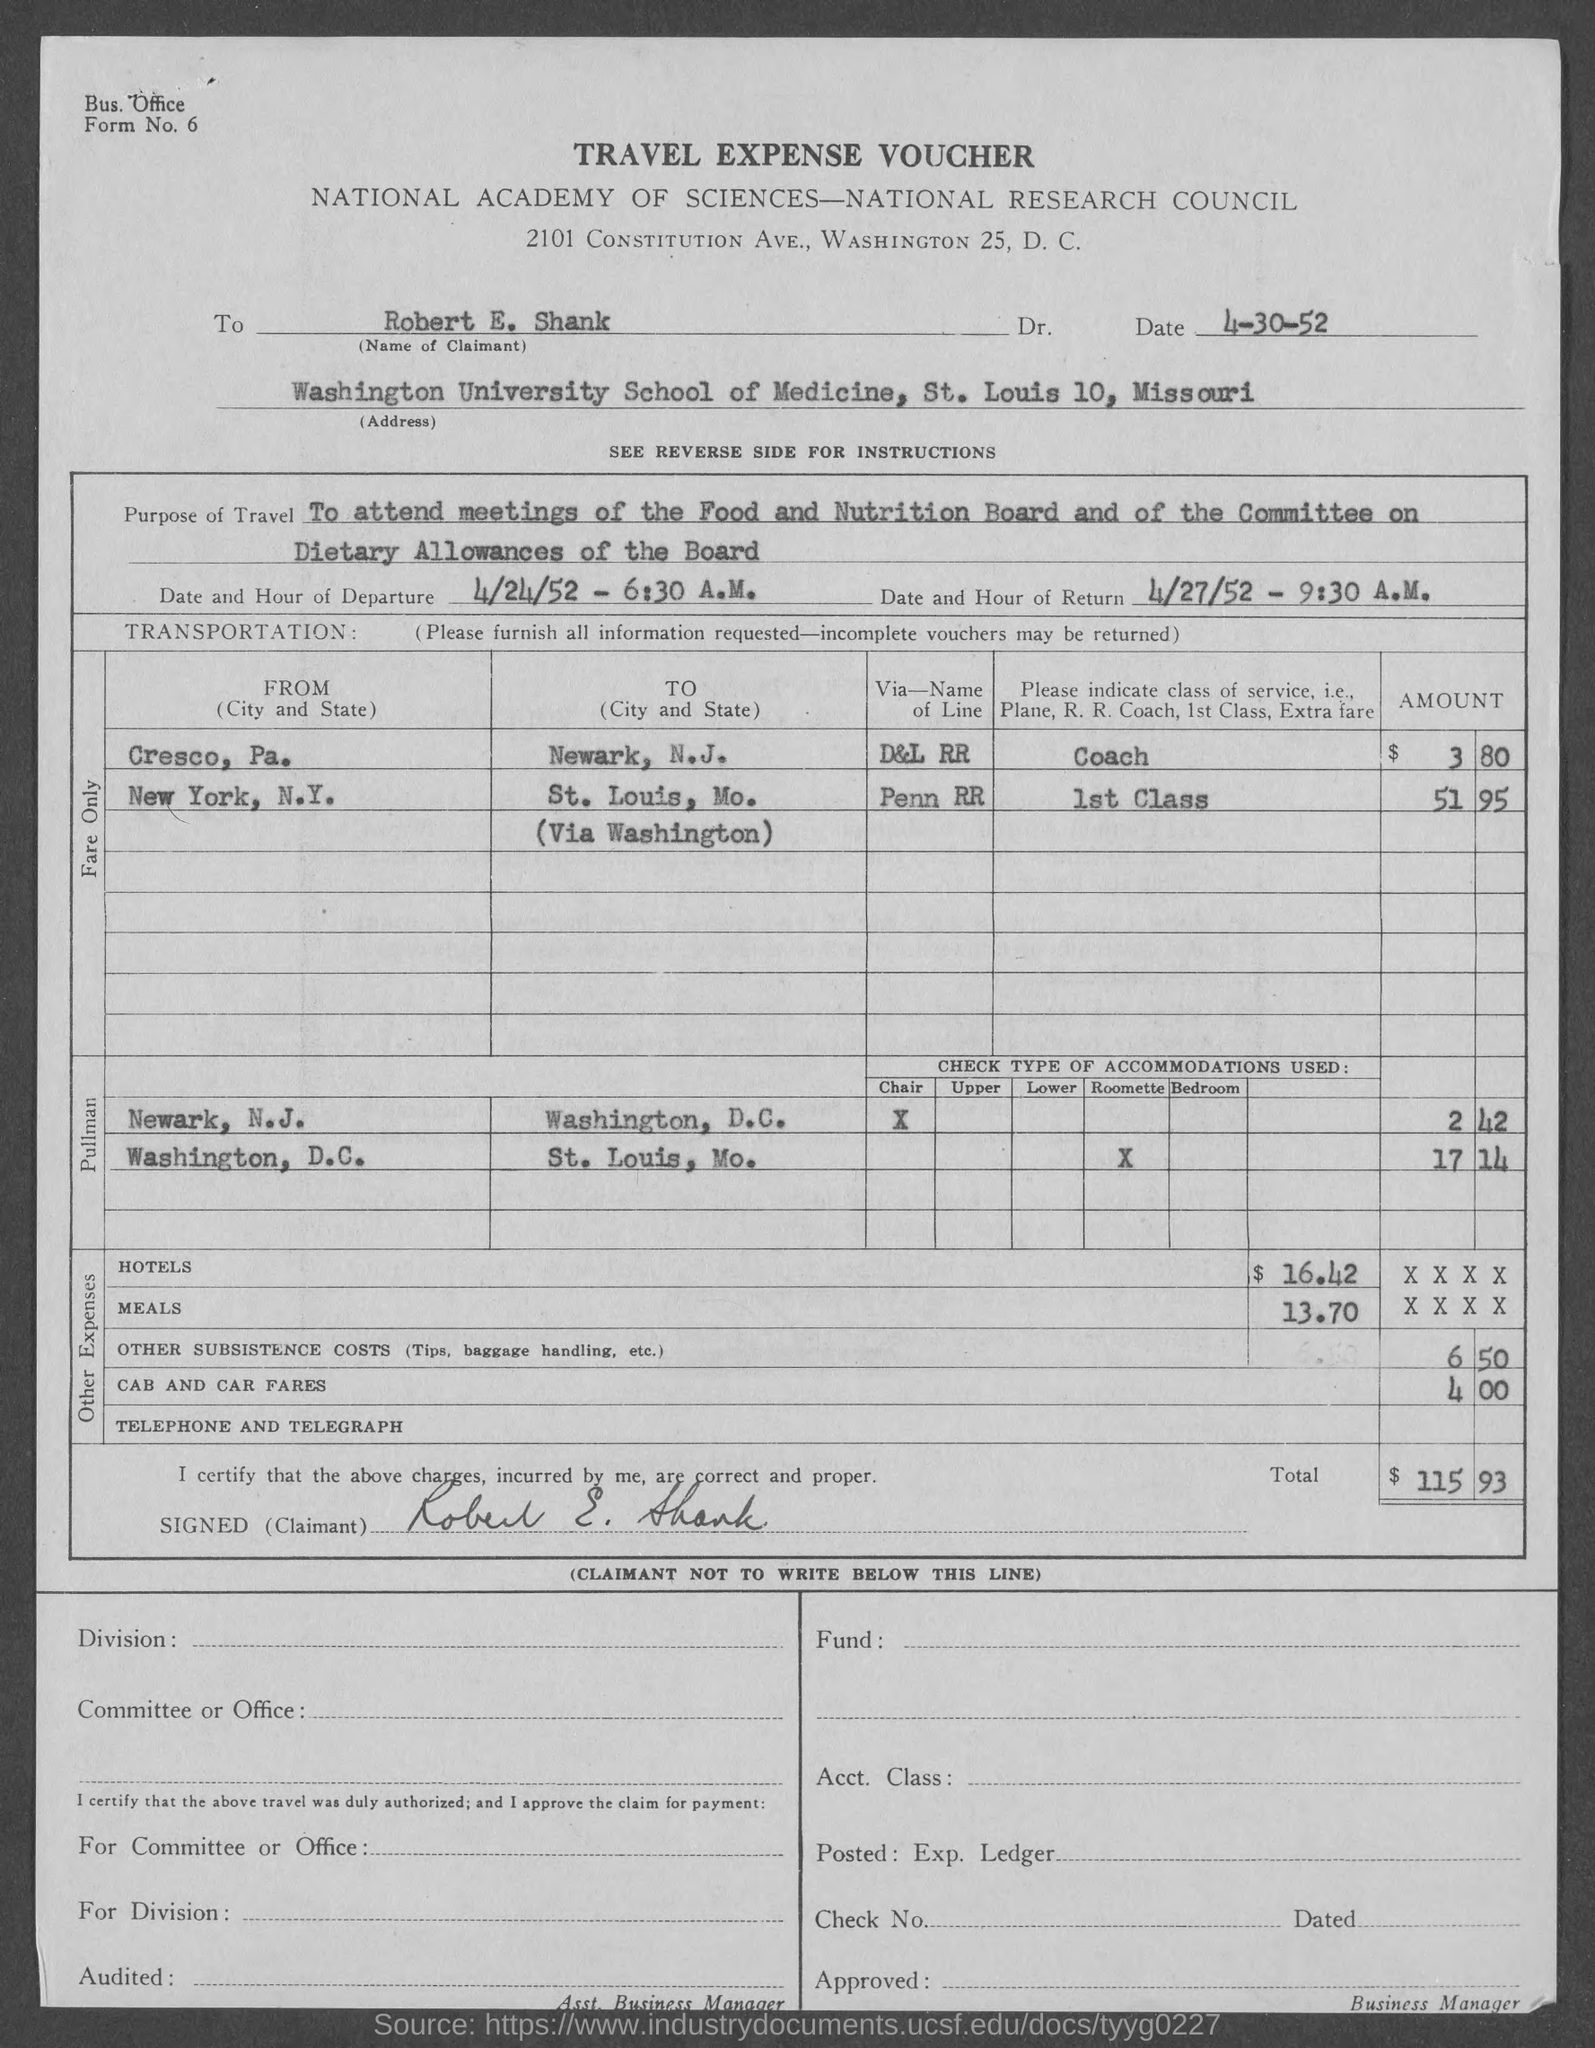Identify some key points in this picture. The purpose of travel mentioned is to attend meetings of the Food and Nutrition Board and the Committee on Dietary Allowances of the Board. The given text states that the date and hour of departure mentioned in the provided page is April 24, 1952, 6:30 A.M. The amount for the hotels mentioned in the given voucher is 16.42... The amount for meals mentioned in the given meals is 13.70. The date and hour of return mentioned in the given form is April 27, 1952 at 9:30 a.m. 